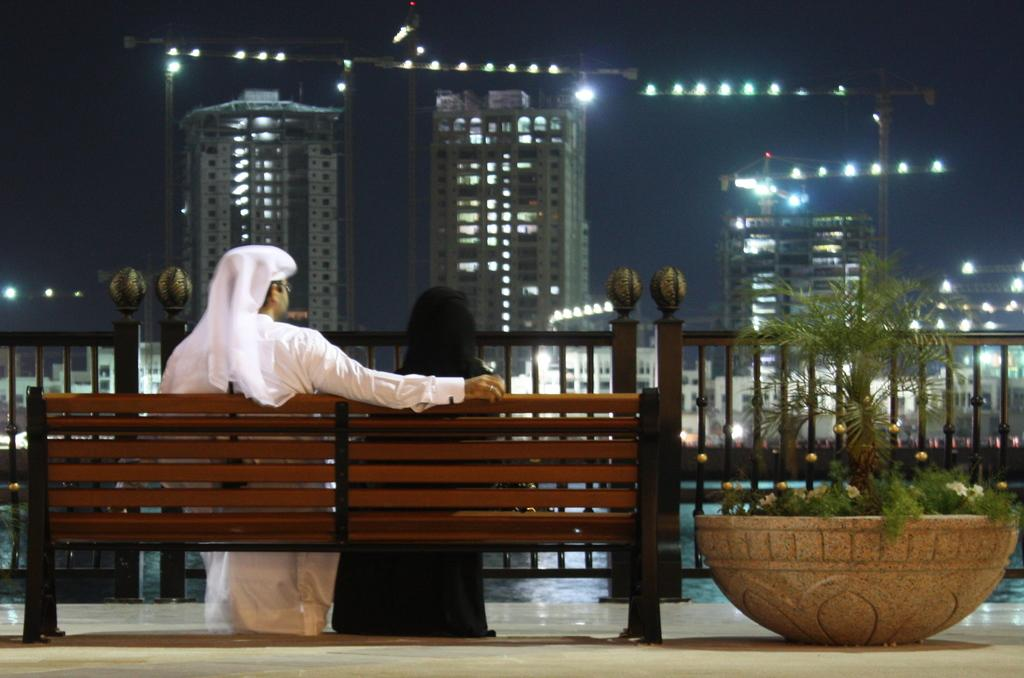Who can be seen in the image? There is a man and a woman in the image. What are they doing in the image? They are sitting on a bench. What can be seen in the foreground of the image? There is a fence and a houseplant on the right side of the image. What is visible in the background of the image? There are buildings, cranes, the sky, and lights in the background of the image. What letter is the man holding in the image? There is no letter present in the image. What type of trade is being conducted in the image? There is no trade being conducted in the image. 